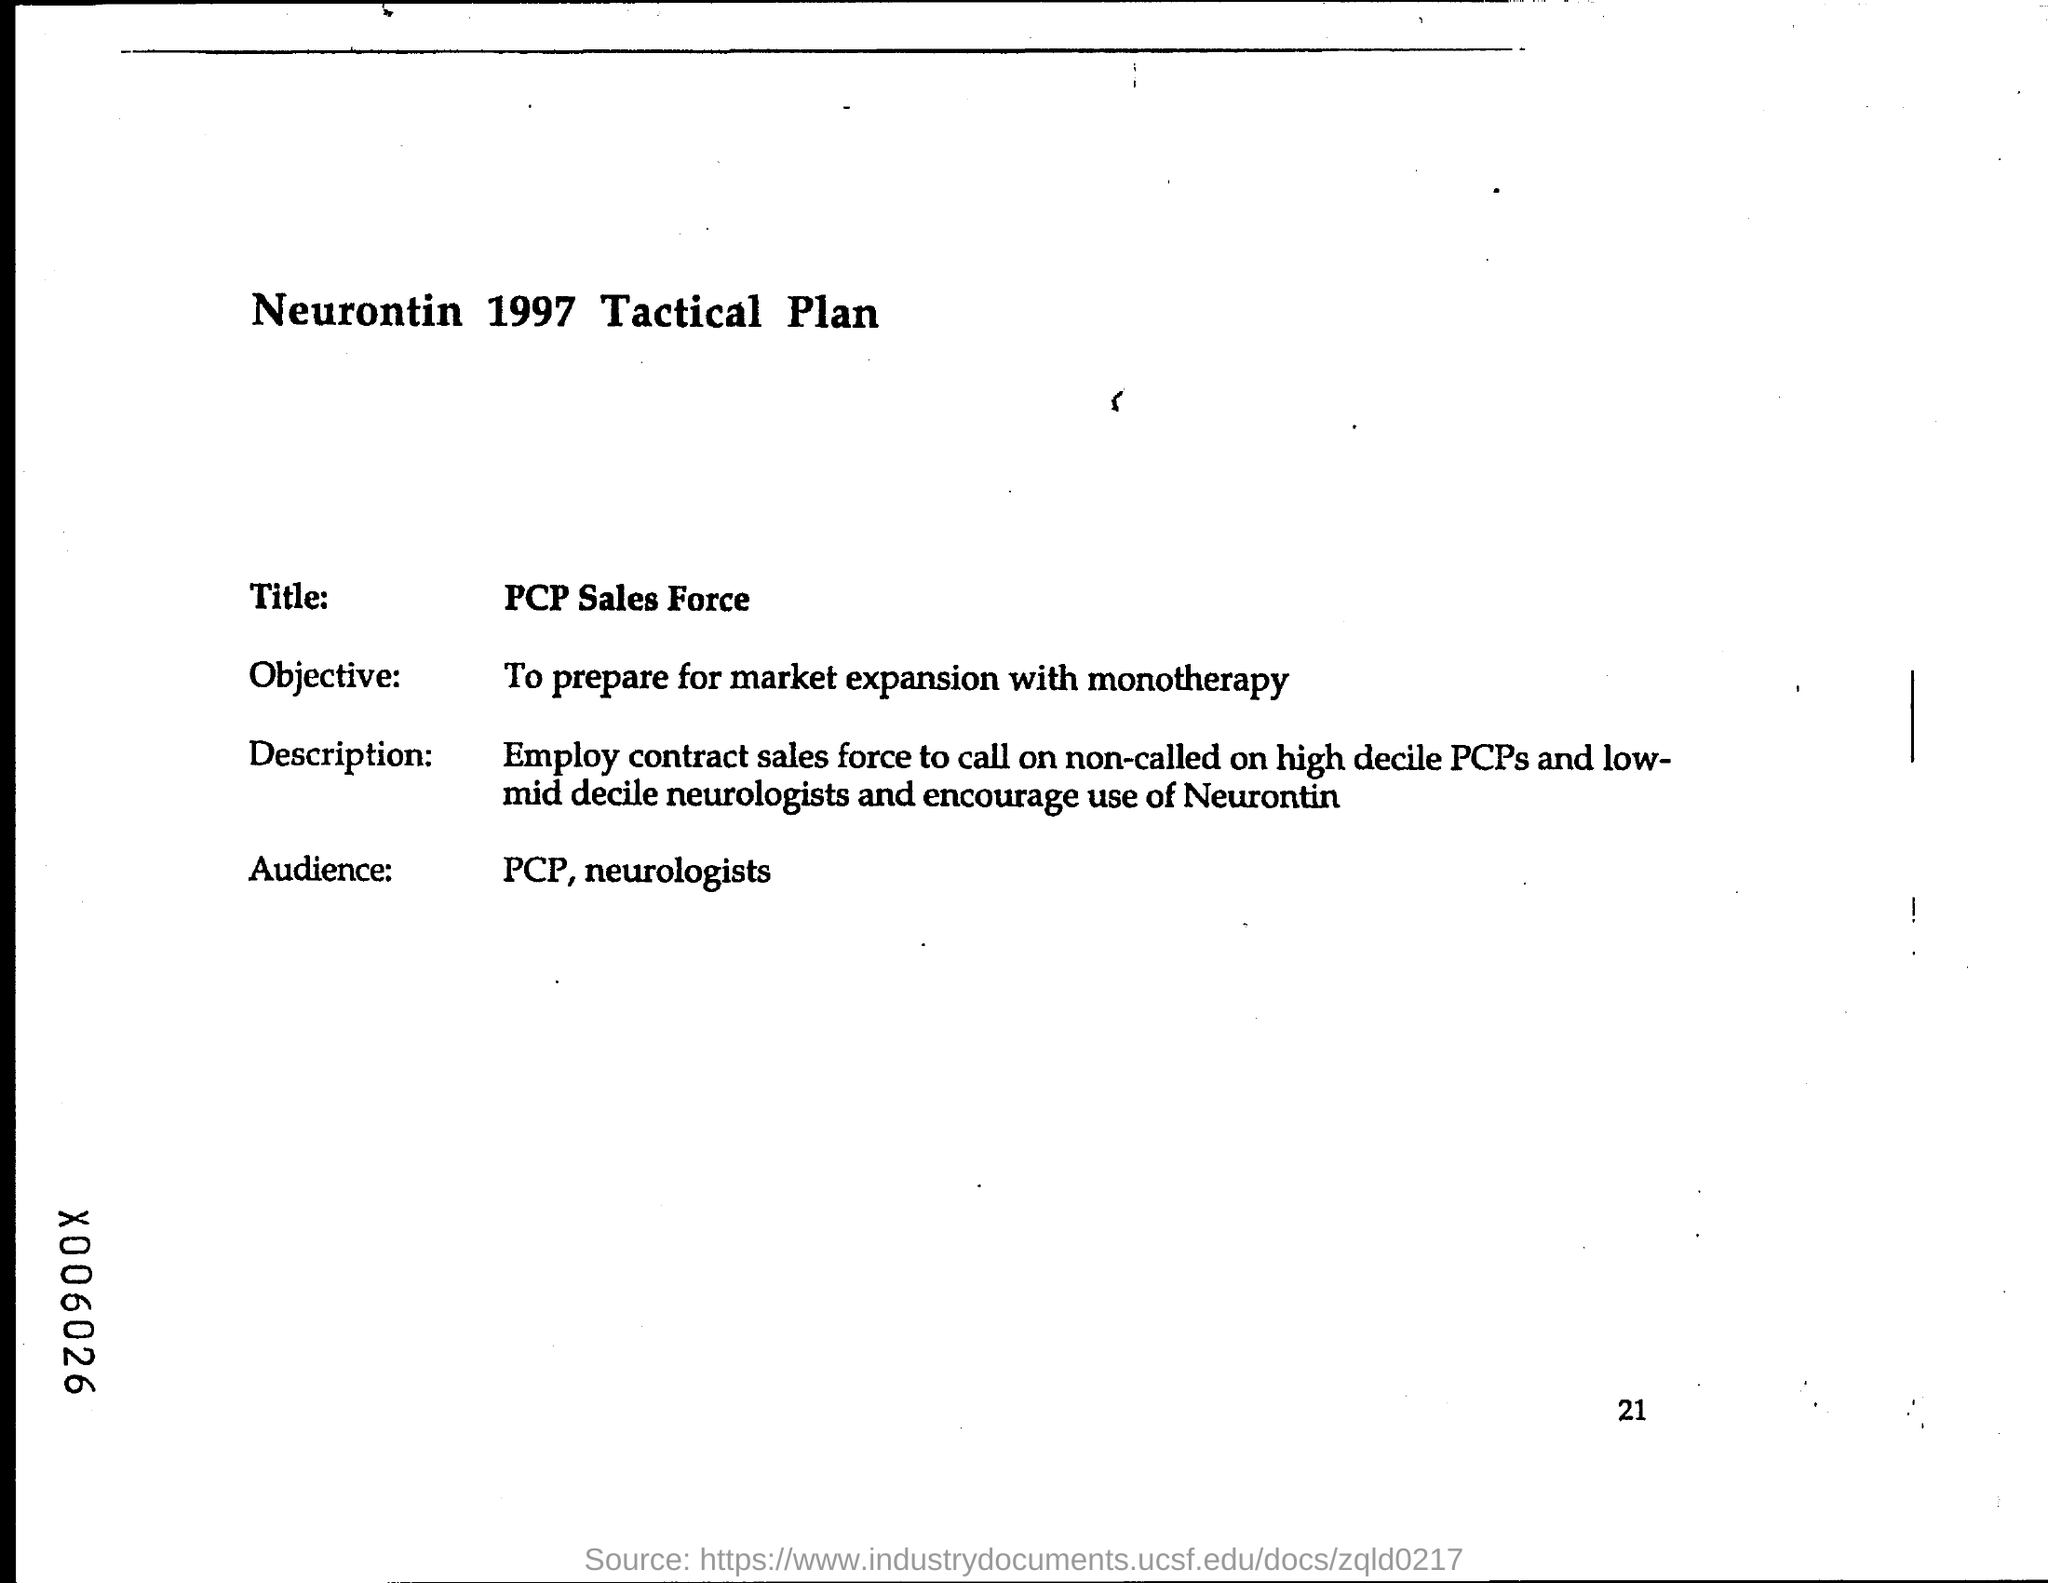What is the title ?
Offer a terse response. PCP sales force. Who are the audience ?
Your response must be concise. PCP, Neurologists. What is the page number at bottom of the page?
Provide a short and direct response. 21. 